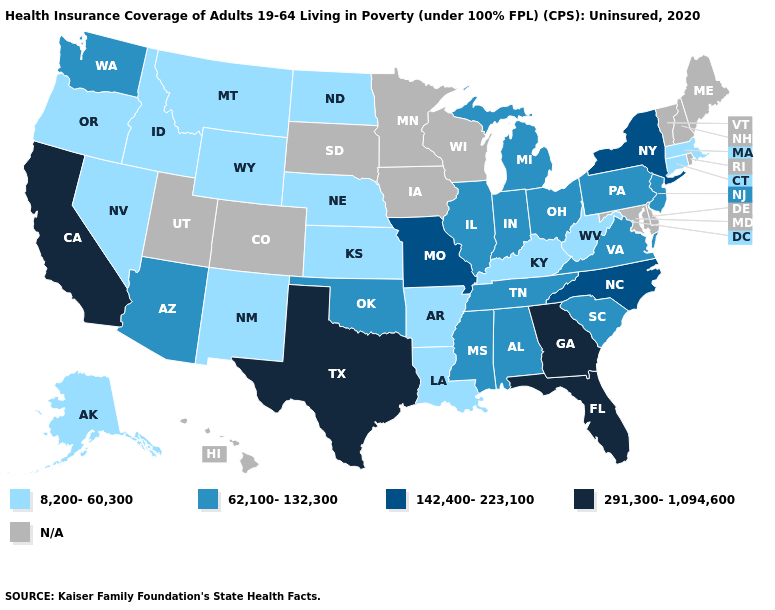What is the value of South Carolina?
Be succinct. 62,100-132,300. How many symbols are there in the legend?
Answer briefly. 5. What is the highest value in the MidWest ?
Give a very brief answer. 142,400-223,100. What is the value of California?
Answer briefly. 291,300-1,094,600. What is the value of Vermont?
Quick response, please. N/A. Name the states that have a value in the range 291,300-1,094,600?
Be succinct. California, Florida, Georgia, Texas. What is the value of Minnesota?
Give a very brief answer. N/A. Among the states that border Rhode Island , which have the lowest value?
Keep it brief. Connecticut, Massachusetts. Among the states that border North Carolina , does Tennessee have the lowest value?
Give a very brief answer. Yes. Among the states that border Illinois , does Missouri have the highest value?
Answer briefly. Yes. Which states have the highest value in the USA?
Write a very short answer. California, Florida, Georgia, Texas. What is the value of Mississippi?
Answer briefly. 62,100-132,300. 